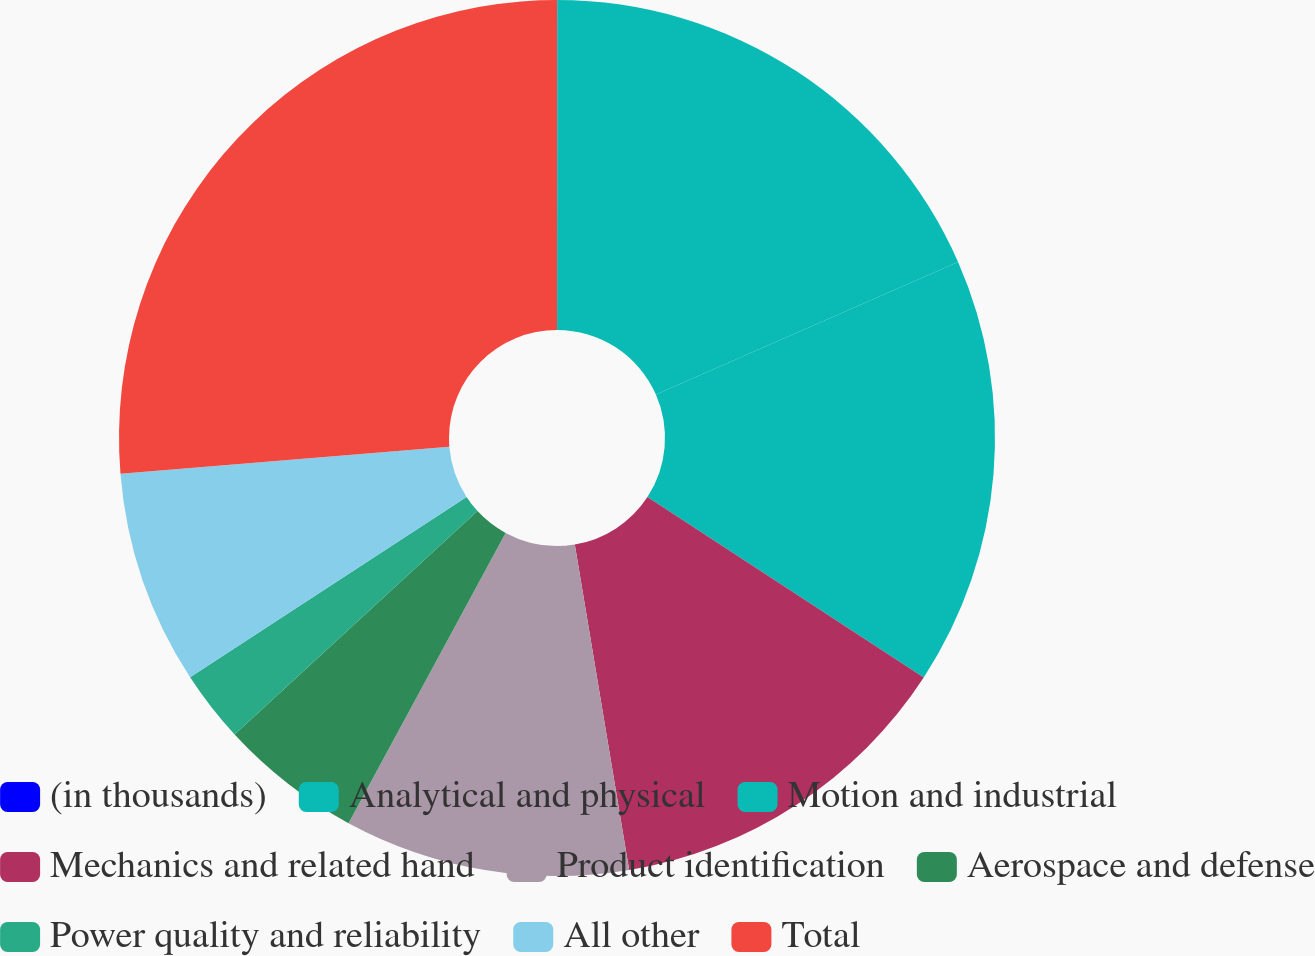Convert chart. <chart><loc_0><loc_0><loc_500><loc_500><pie_chart><fcel>(in thousands)<fcel>Analytical and physical<fcel>Motion and industrial<fcel>Mechanics and related hand<fcel>Product identification<fcel>Aerospace and defense<fcel>Power quality and reliability<fcel>All other<fcel>Total<nl><fcel>0.01%<fcel>18.41%<fcel>15.79%<fcel>13.16%<fcel>10.53%<fcel>5.27%<fcel>2.64%<fcel>7.9%<fcel>26.3%<nl></chart> 